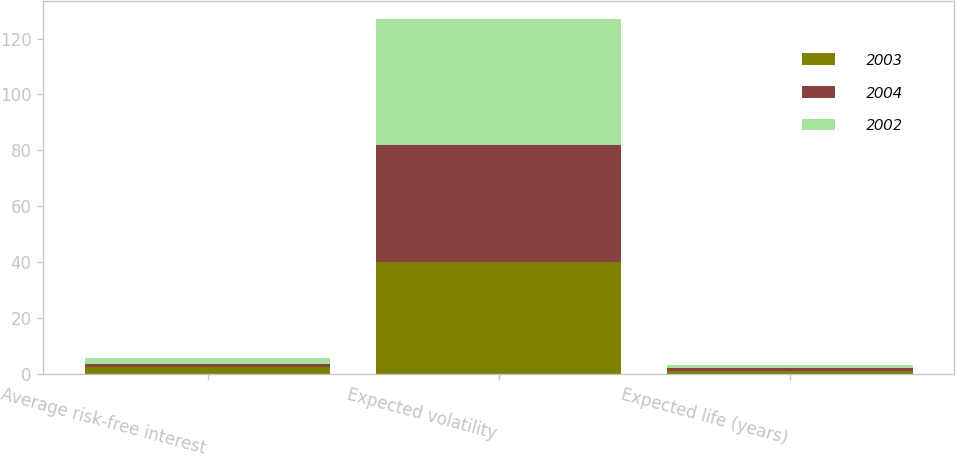Convert chart to OTSL. <chart><loc_0><loc_0><loc_500><loc_500><stacked_bar_chart><ecel><fcel>Average risk-free interest<fcel>Expected volatility<fcel>Expected life (years)<nl><fcel>2003<fcel>2.2<fcel>40<fcel>1<nl><fcel>2004<fcel>1.3<fcel>42<fcel>1<nl><fcel>2002<fcel>2.1<fcel>45<fcel>1<nl></chart> 